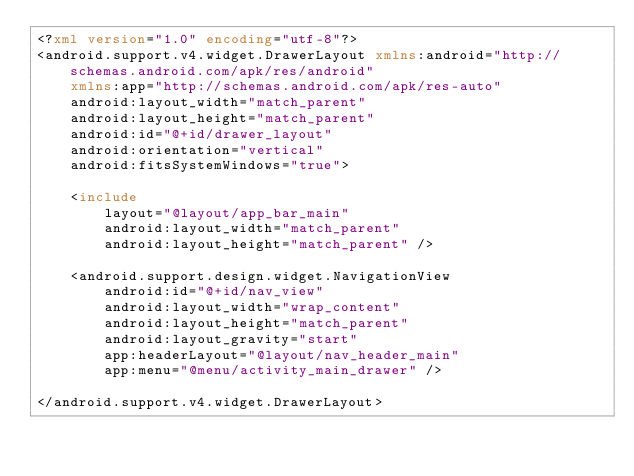Convert code to text. <code><loc_0><loc_0><loc_500><loc_500><_XML_><?xml version="1.0" encoding="utf-8"?>
<android.support.v4.widget.DrawerLayout xmlns:android="http://schemas.android.com/apk/res/android"
    xmlns:app="http://schemas.android.com/apk/res-auto"
    android:layout_width="match_parent"
    android:layout_height="match_parent"
    android:id="@+id/drawer_layout"
    android:orientation="vertical"
    android:fitsSystemWindows="true">

    <include
        layout="@layout/app_bar_main"
        android:layout_width="match_parent"
        android:layout_height="match_parent" />

    <android.support.design.widget.NavigationView
        android:id="@+id/nav_view"
        android:layout_width="wrap_content"
        android:layout_height="match_parent"
        android:layout_gravity="start"
        app:headerLayout="@layout/nav_header_main"
        app:menu="@menu/activity_main_drawer" />

</android.support.v4.widget.DrawerLayout>
</code> 